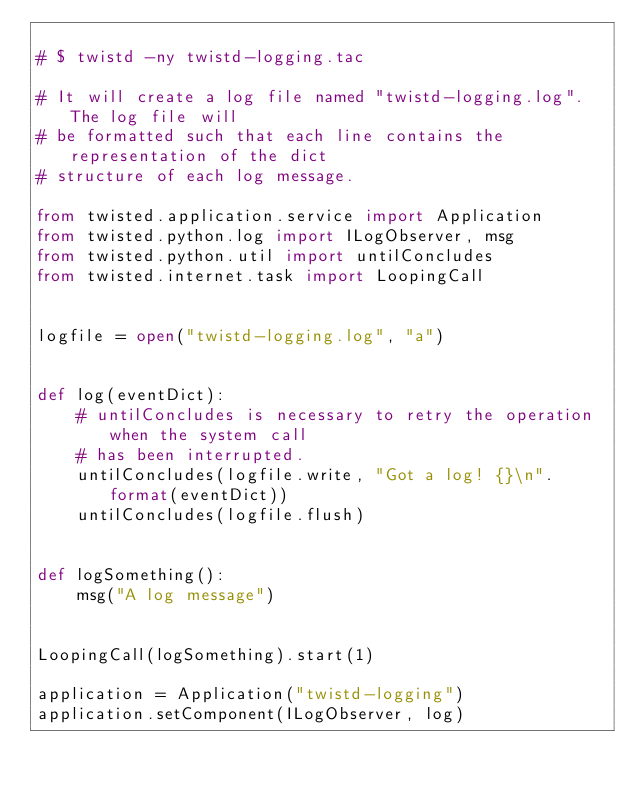<code> <loc_0><loc_0><loc_500><loc_500><_Python_>
# $ twistd -ny twistd-logging.tac

# It will create a log file named "twistd-logging.log".  The log file will
# be formatted such that each line contains the representation of the dict
# structure of each log message.

from twisted.application.service import Application
from twisted.python.log import ILogObserver, msg
from twisted.python.util import untilConcludes
from twisted.internet.task import LoopingCall


logfile = open("twistd-logging.log", "a")


def log(eventDict):
    # untilConcludes is necessary to retry the operation when the system call
    # has been interrupted.
    untilConcludes(logfile.write, "Got a log! {}\n".format(eventDict))
    untilConcludes(logfile.flush)


def logSomething():
    msg("A log message")


LoopingCall(logSomething).start(1)

application = Application("twistd-logging")
application.setComponent(ILogObserver, log)
</code> 